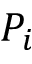<formula> <loc_0><loc_0><loc_500><loc_500>P _ { i }</formula> 